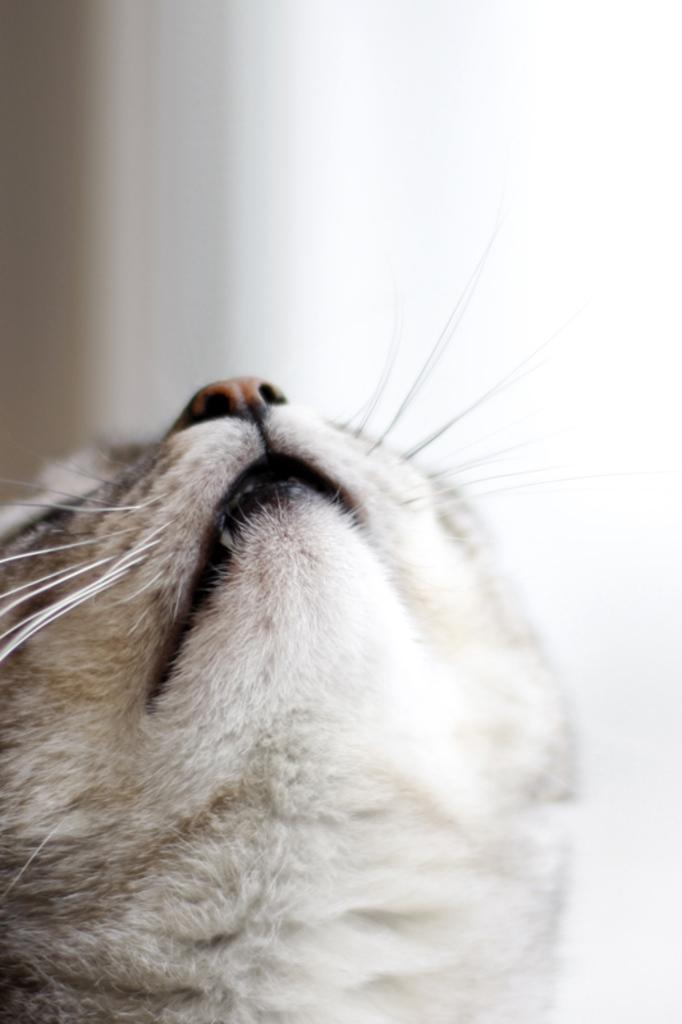What type of animal's head is visible in the image? There is the head of a cat in the image. What type of flower is present in the image? There is no flower present in the image; it only features the head of a cat. 